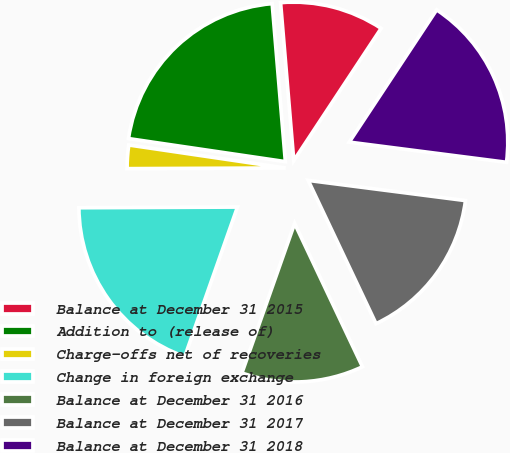Convert chart to OTSL. <chart><loc_0><loc_0><loc_500><loc_500><pie_chart><fcel>Balance at December 31 2015<fcel>Addition to (release of)<fcel>Charge-offs net of recoveries<fcel>Change in foreign exchange<fcel>Balance at December 31 2016<fcel>Balance at December 31 2017<fcel>Balance at December 31 2018<nl><fcel>10.62%<fcel>21.35%<fcel>2.39%<fcel>19.54%<fcel>12.43%<fcel>15.93%<fcel>17.74%<nl></chart> 